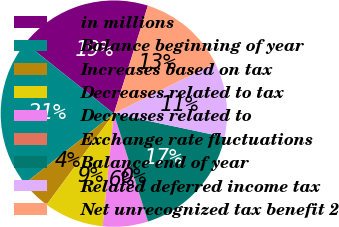<chart> <loc_0><loc_0><loc_500><loc_500><pie_chart><fcel>in millions<fcel>Balance beginning of year<fcel>Increases based on tax<fcel>Decreases related to tax<fcel>Decreases related to<fcel>Exchange rate fluctuations<fcel>Balance end of year<fcel>Related deferred income tax<fcel>Net unrecognized tax benefit 2<nl><fcel>19.16%<fcel>21.29%<fcel>4.3%<fcel>8.54%<fcel>6.42%<fcel>0.05%<fcel>16.8%<fcel>10.67%<fcel>12.79%<nl></chart> 